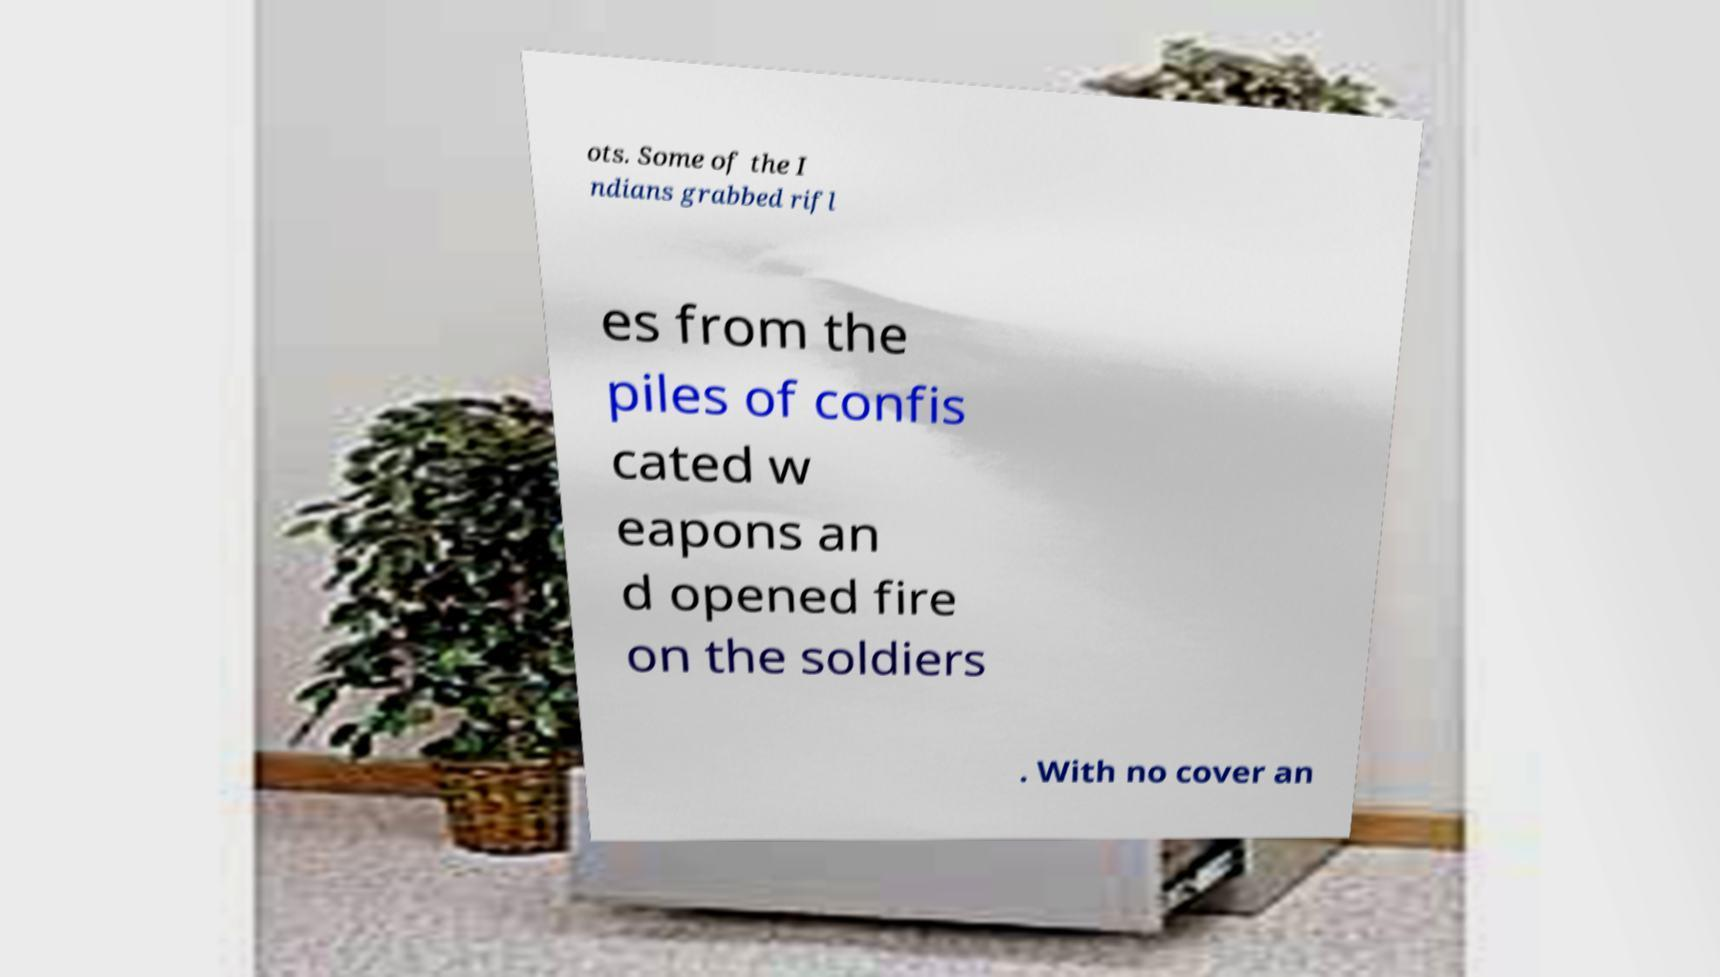Could you assist in decoding the text presented in this image and type it out clearly? ots. Some of the I ndians grabbed rifl es from the piles of confis cated w eapons an d opened fire on the soldiers . With no cover an 